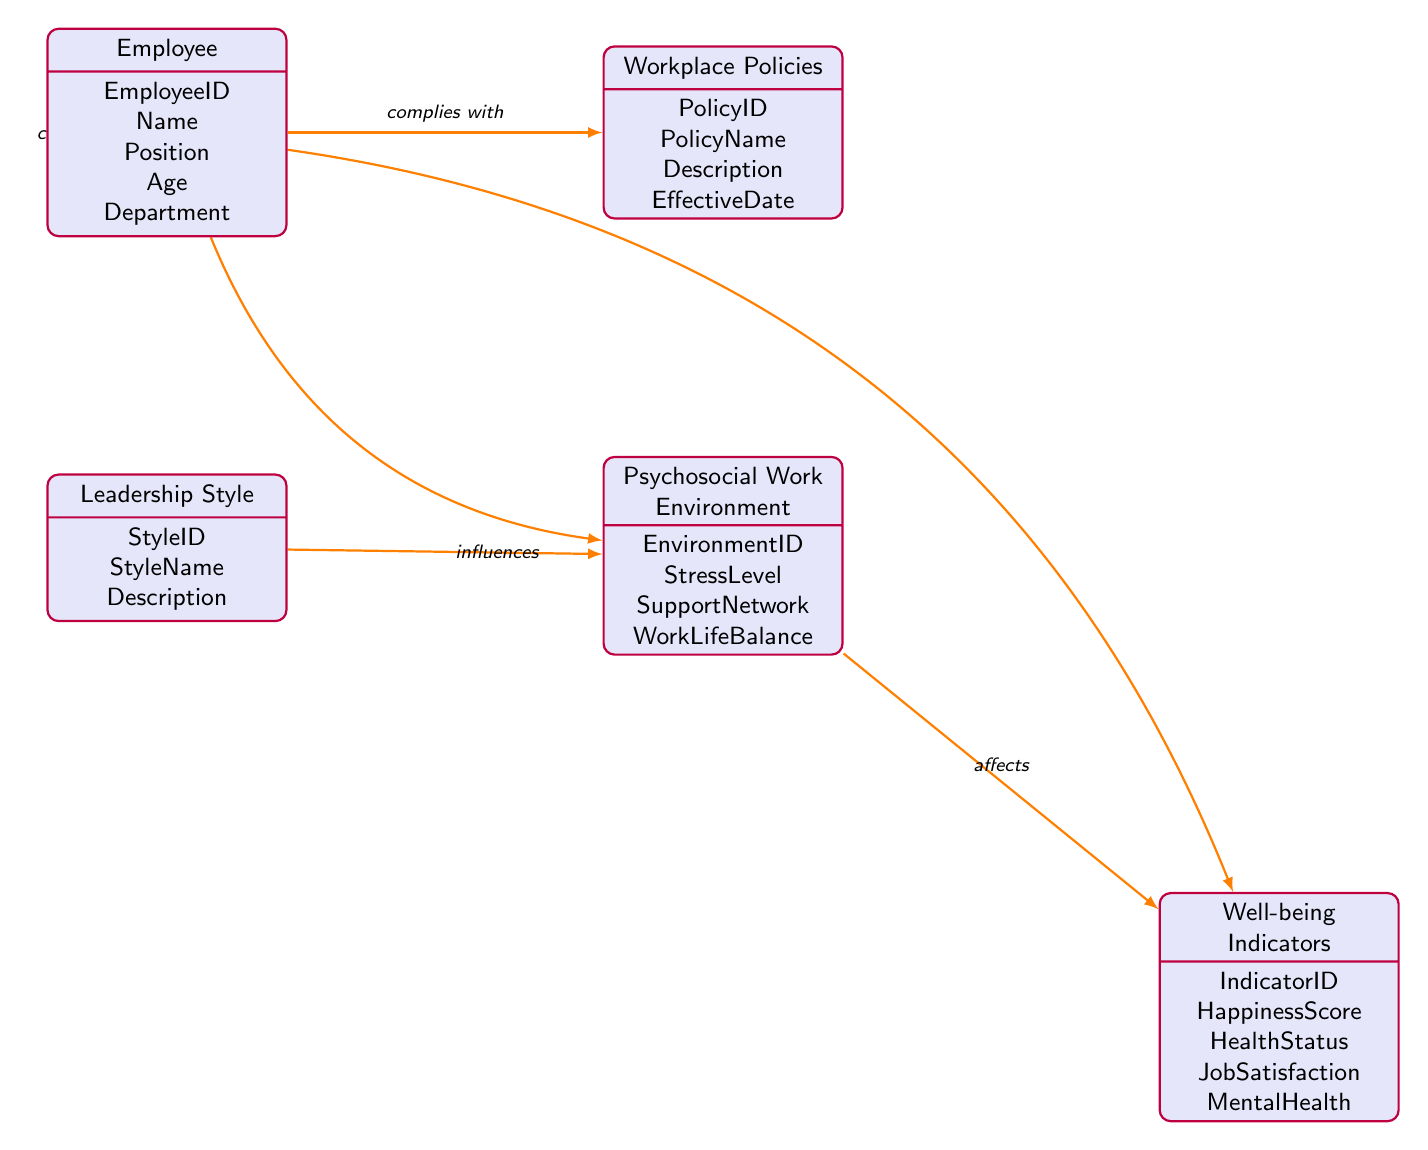What entities are represented in the diagram? The diagram includes five entities: Employee, Workplace Policies, Leadership Style, Psychosocial Work Environment, and Well-being Indicators.
Answer: Employee, Workplace Policies, Leadership Style, Psychosocial Work Environment, Well-being Indicators How many attributes does the "Employee" entity have? The "Employee" entity has five attributes listed: EmployeeID, Name, Position, Age, and Department.
Answer: 5 What is the relationship type between "Leadership Style" and "Psychosocial Work Environment"? The relationship type between these two entities is shown as "influences."
Answer: influences Which entity contributes to the "Psychosocial Work Environment"? According to the diagram, the entity that contributes to the "Psychosocial Work Environment" is the "Employee."
Answer: Employee What entities are monitored by "Well-being Indicators"? The "Well-being Indicators" node is monitored by the "Employee" entity according to the diagram.
Answer: Employee How does the "Workplace Policies" interact with "Employee"? The interaction between "Workplace Policies" and "Employee" is represented as "complies with" in the diagram.
Answer: complies with What is the flow of influence from "Leadership Style" to "Well-being Indicators"? The flow starts with "Leadership Style" influencing the "Psychosocial Work Environment," which then affects the "Well-being Indicators."
Answer: Leadership Style to Psychosocial Work Environment to Well-being Indicators How many relationships are depicted in the diagram? The diagram illustrates five relationships connecting the entities.
Answer: 5 What is the attribute representing job satisfaction in the "Well-being Indicators"? The "JobSatisfaction" attribute is used to represent job satisfaction in the "Well-being Indicators."
Answer: JobSatisfaction 